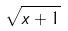<formula> <loc_0><loc_0><loc_500><loc_500>\sqrt { x + 1 }</formula> 